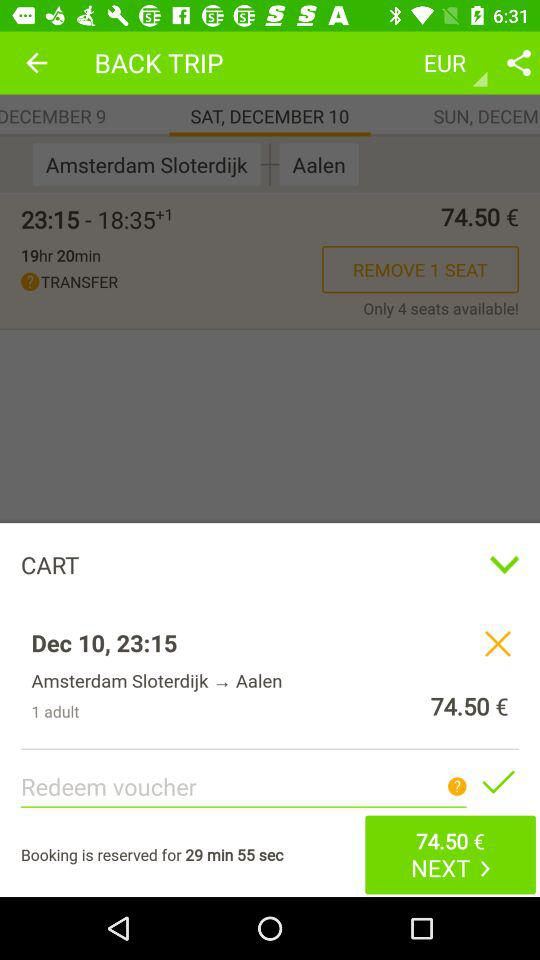What is the fare of the trip from Amsterdam to Aalen? The fare is €74.50. 